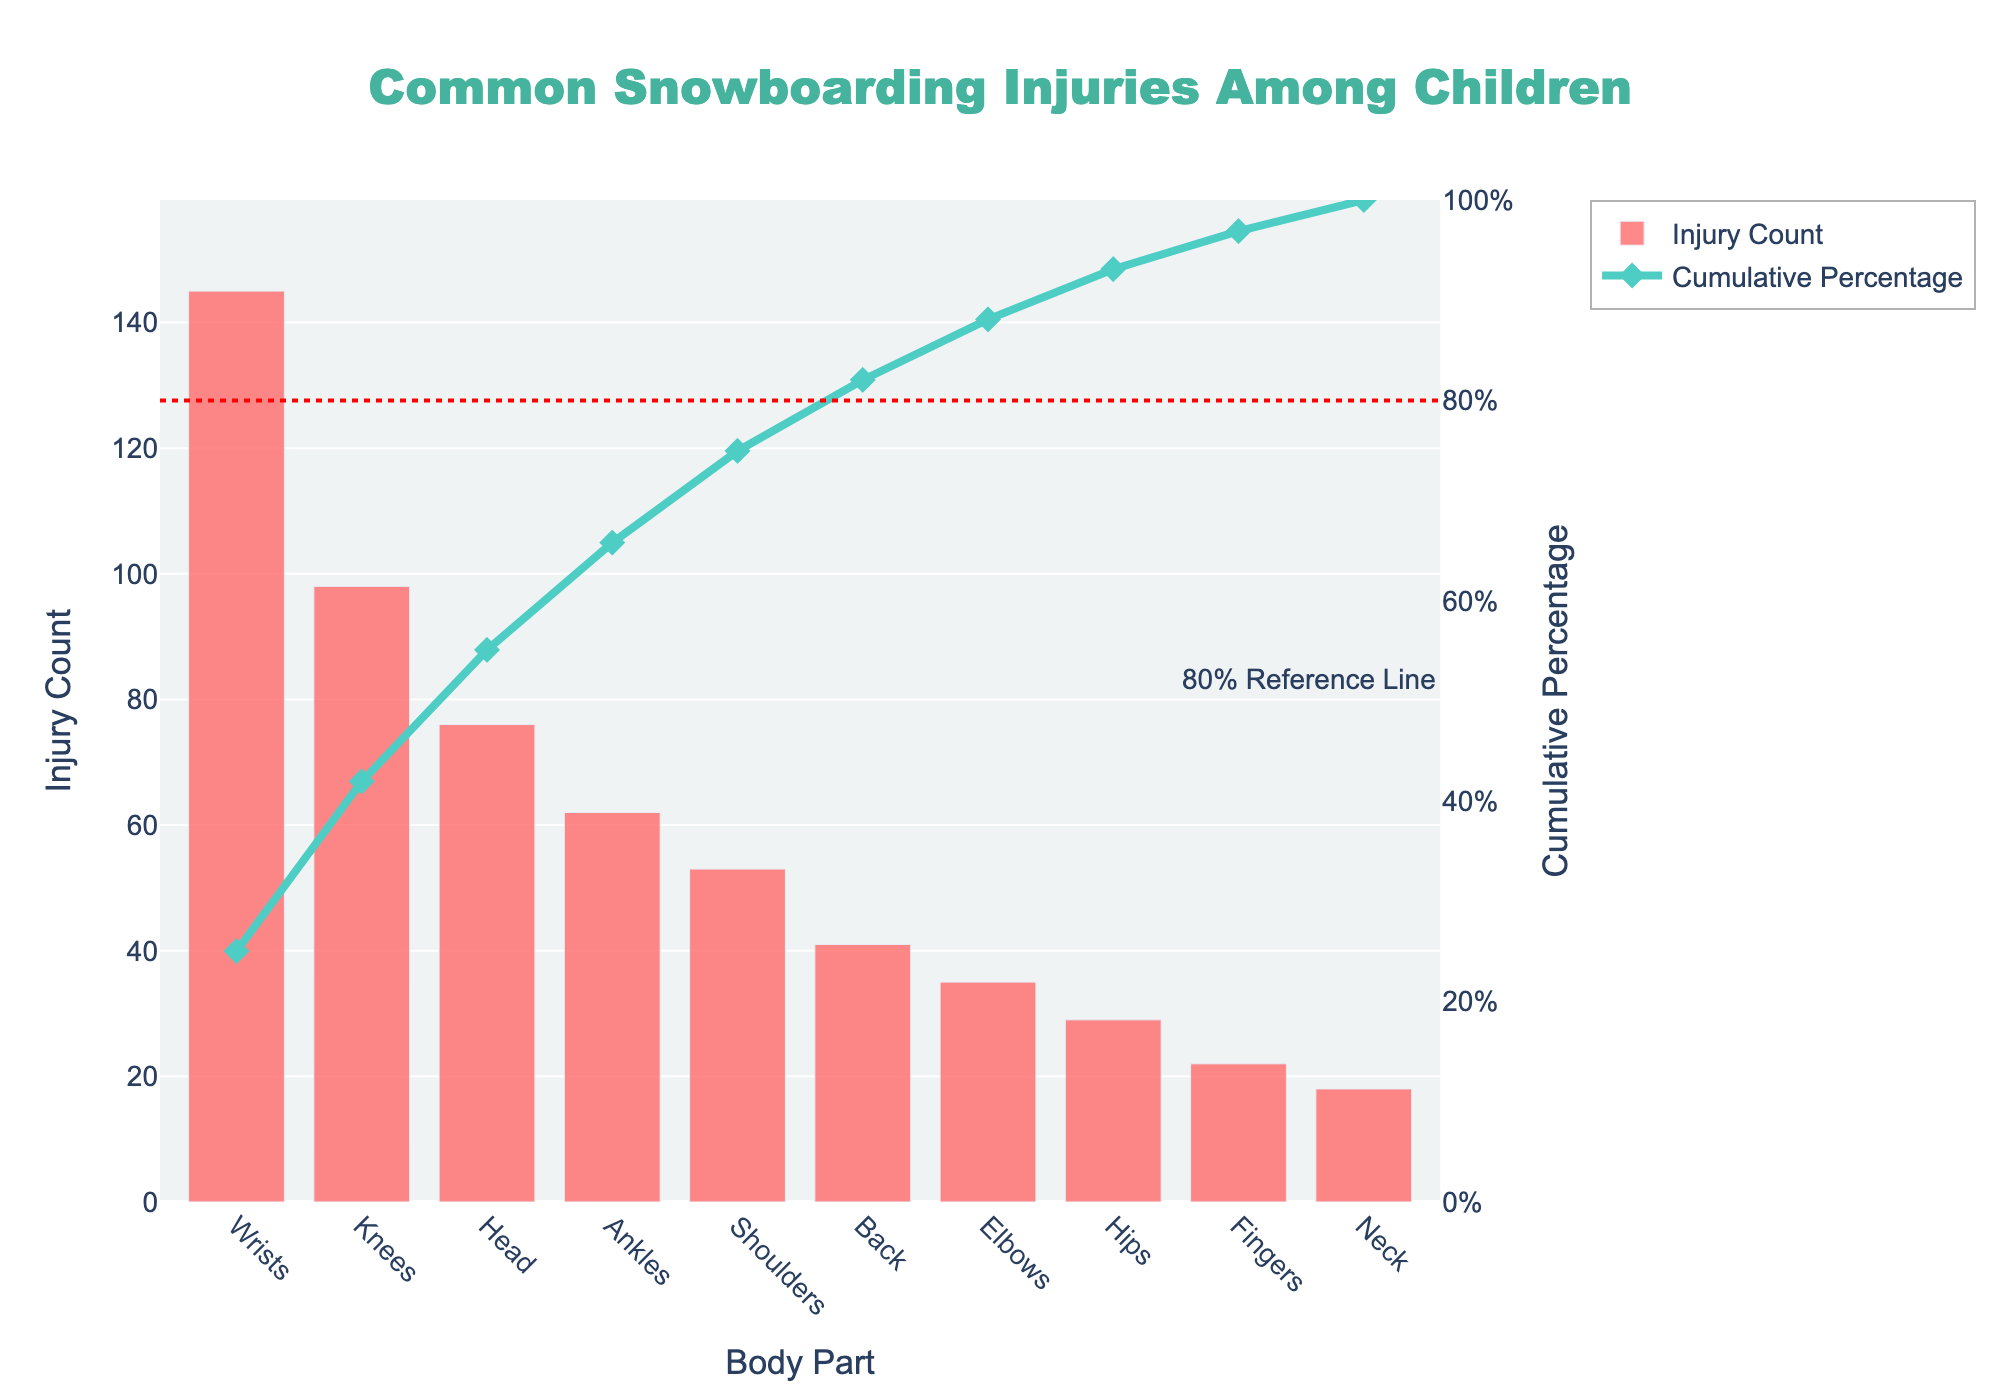What's the total number of injuries reported? To find the total number of injuries, sum up all the counts reported for each body part. That is 145 (Wrists) + 98 (Knees) + 76 (Head) + 62 (Ankles) + 53 (Shoulders) + 41 (Back) + 35 (Elbows) + 29 (Hips) + 22 (Fingers) + 18 (Neck) which equals 579.
Answer: 579 Which body part has the highest number of injuries? The body part with the highest number of injuries is identified by the bar with the greatest height. The chart shows Wrists with the highest number of injuries (145).
Answer: Wrists What percentage of total injuries do wrist injuries represent? Wrist injuries count is 145. To find the percentage, divide 145 by the total number of injuries (579) and multiply by 100. The calculation is (145 / 579) * 100 = 25.04%.
Answer: 25.04% What is the cumulative percentage of the top three injured body parts? The cumulative percentage of the top three injured body parts (Wrists, Knees, and Head) is given on the secondary axis above the tallest bars for these body parts. The third bar (Head) shows a cumulative percentage of around 54%.
Answer: 54% What proportion of injuries are represented by the top five body parts? Sum the injury counts for the top five body parts: Wrists (145), Knees (98), Head (76), Ankles (62), and Shoulders (53). The total is 145 + 98 + 76 + 62 + 53 = 434. The proportion is calculated by (434 / 579) which equals roughly 0.749.
Answer: ~75% Is there a reference line in the plot? If yes, what does it represent? Yes, there's a dotted red line in the plot that represents the 80% cumulative percentage mark. It's there to help visualize which body parts cumulatively contribute to 80% of the injuries.
Answer: 80% reference line How many body parts collectively account for roughly 80% of the total injuries? Refer to the cumulative percentage line (green) and the 80% reference line (red). The point where they intersect indicates that the top six body parts (Wrists, Knees, Head, Ankles, Shoulders, Back) contribute to roughly 80% of total injuries.
Answer: Six body parts Which body part has the least number of injuries? The body part with the least number of injuries is identified by the shortest bar. The chart shows Neck with the least number of injuries (18).
Answer: Neck How does the number of knee injuries compare to ankle injuries? Knee injuries are represented by a taller bar than ankle injuries. Knees have 98 injuries while Ankles have 62. Knee injuries are greater than ankle injuries.
Answer: Knee injuries > Ankle injuries 